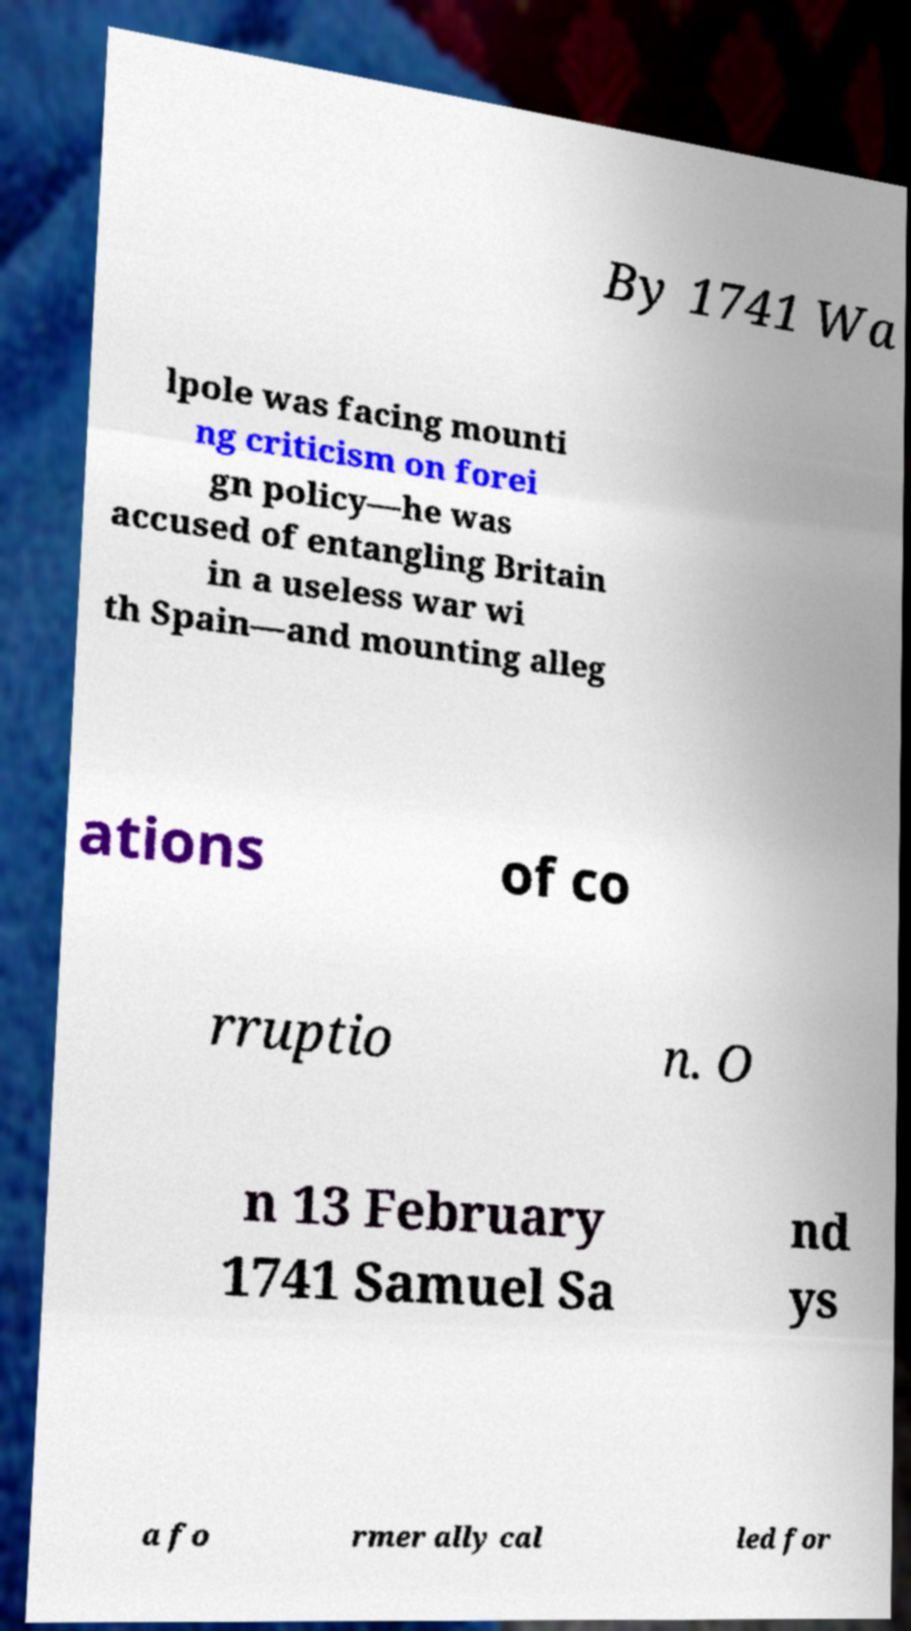What messages or text are displayed in this image? I need them in a readable, typed format. By 1741 Wa lpole was facing mounti ng criticism on forei gn policy—he was accused of entangling Britain in a useless war wi th Spain—and mounting alleg ations of co rruptio n. O n 13 February 1741 Samuel Sa nd ys a fo rmer ally cal led for 